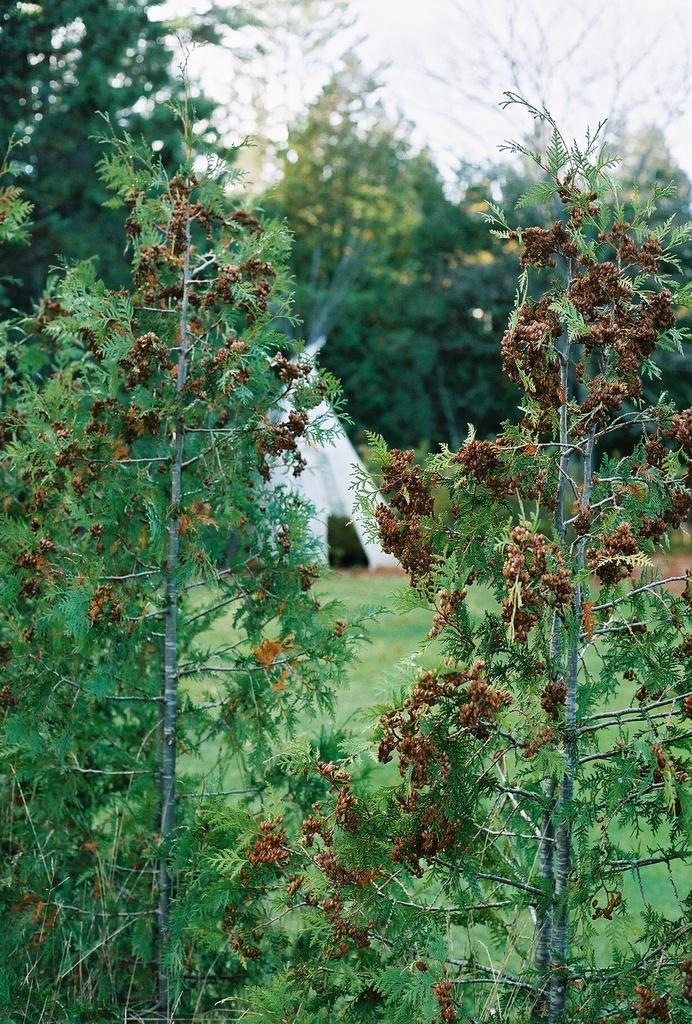In one or two sentences, can you explain what this image depicts? Here I can see some plants along with the flowers. In the background there is a tent and many trees. At the top of the image I can see the sky. 